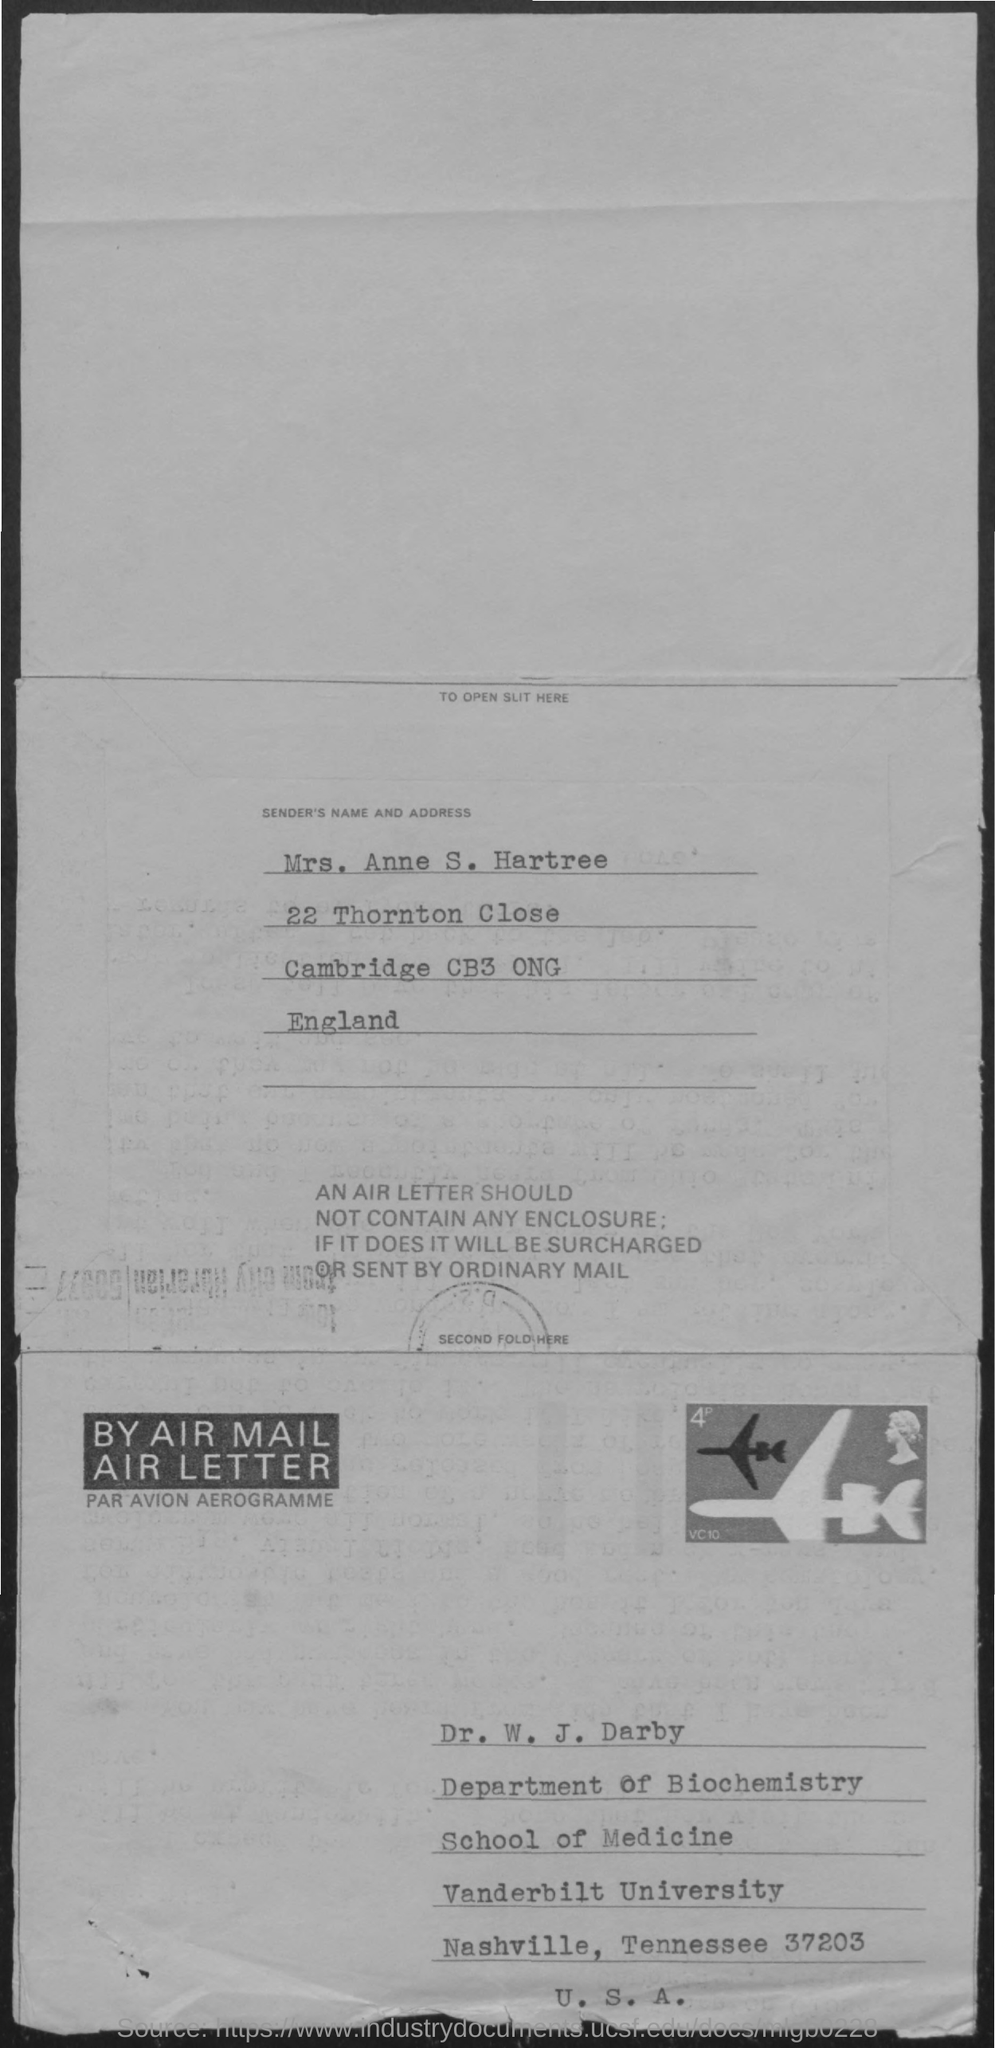Mention a couple of crucial points in this snapshot. The sender's name mentioned in the address is "Mrs. Anne S. Hartree. 